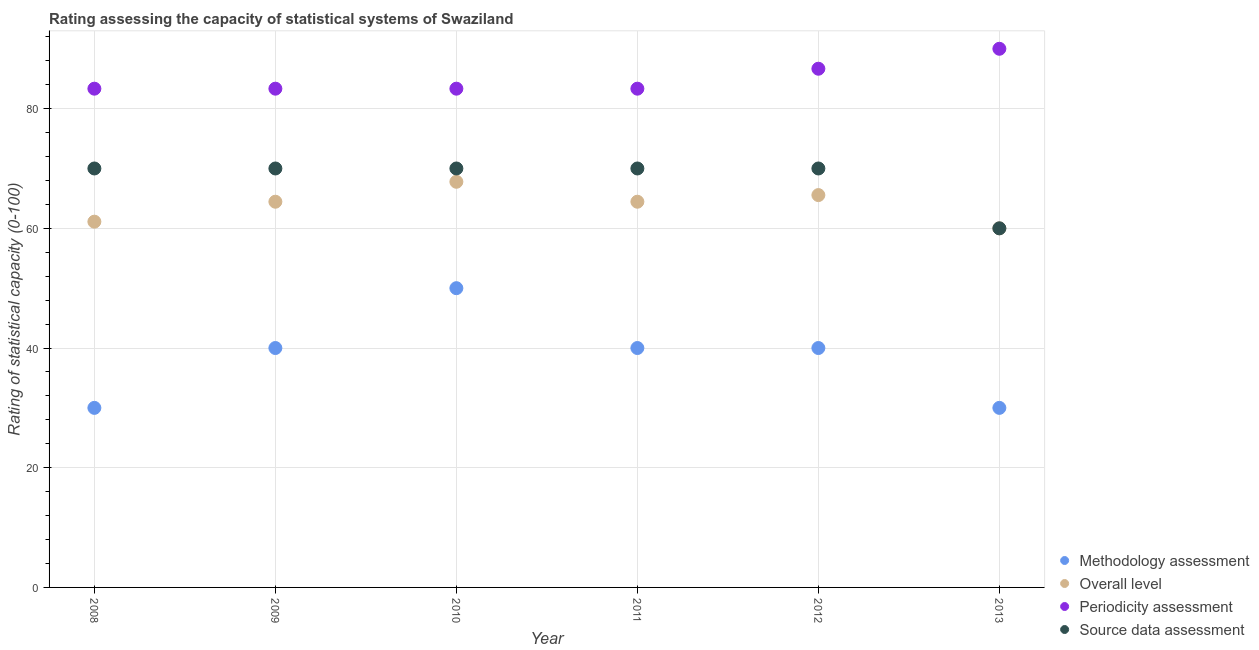What is the methodology assessment rating in 2008?
Give a very brief answer. 30. Across all years, what is the maximum methodology assessment rating?
Provide a short and direct response. 50. Across all years, what is the minimum overall level rating?
Provide a short and direct response. 60. In which year was the source data assessment rating maximum?
Your response must be concise. 2008. In which year was the periodicity assessment rating minimum?
Your answer should be compact. 2008. What is the total methodology assessment rating in the graph?
Offer a terse response. 230. What is the difference between the overall level rating in 2010 and that in 2012?
Provide a short and direct response. 2.22. What is the difference between the source data assessment rating in 2010 and the periodicity assessment rating in 2008?
Offer a terse response. -13.33. What is the average source data assessment rating per year?
Offer a terse response. 68.33. In the year 2010, what is the difference between the periodicity assessment rating and source data assessment rating?
Keep it short and to the point. 13.33. What is the ratio of the source data assessment rating in 2008 to that in 2009?
Offer a terse response. 1. Is the methodology assessment rating in 2008 less than that in 2012?
Give a very brief answer. Yes. What is the difference between the highest and the second highest periodicity assessment rating?
Your response must be concise. 3.33. What is the difference between the highest and the lowest overall level rating?
Your response must be concise. 7.78. In how many years, is the periodicity assessment rating greater than the average periodicity assessment rating taken over all years?
Make the answer very short. 2. Is it the case that in every year, the sum of the overall level rating and methodology assessment rating is greater than the sum of periodicity assessment rating and source data assessment rating?
Offer a very short reply. No. Is the methodology assessment rating strictly greater than the overall level rating over the years?
Make the answer very short. No. Is the overall level rating strictly less than the source data assessment rating over the years?
Your answer should be compact. No. How many dotlines are there?
Provide a succinct answer. 4. What is the difference between two consecutive major ticks on the Y-axis?
Offer a very short reply. 20. Does the graph contain any zero values?
Provide a succinct answer. No. Does the graph contain grids?
Keep it short and to the point. Yes. Where does the legend appear in the graph?
Keep it short and to the point. Bottom right. How many legend labels are there?
Make the answer very short. 4. How are the legend labels stacked?
Offer a terse response. Vertical. What is the title of the graph?
Offer a terse response. Rating assessing the capacity of statistical systems of Swaziland. Does "Labor Taxes" appear as one of the legend labels in the graph?
Ensure brevity in your answer.  No. What is the label or title of the Y-axis?
Provide a short and direct response. Rating of statistical capacity (0-100). What is the Rating of statistical capacity (0-100) of Methodology assessment in 2008?
Offer a terse response. 30. What is the Rating of statistical capacity (0-100) of Overall level in 2008?
Keep it short and to the point. 61.11. What is the Rating of statistical capacity (0-100) of Periodicity assessment in 2008?
Offer a very short reply. 83.33. What is the Rating of statistical capacity (0-100) of Source data assessment in 2008?
Provide a succinct answer. 70. What is the Rating of statistical capacity (0-100) of Overall level in 2009?
Your answer should be very brief. 64.44. What is the Rating of statistical capacity (0-100) in Periodicity assessment in 2009?
Your response must be concise. 83.33. What is the Rating of statistical capacity (0-100) in Source data assessment in 2009?
Your response must be concise. 70. What is the Rating of statistical capacity (0-100) in Overall level in 2010?
Provide a succinct answer. 67.78. What is the Rating of statistical capacity (0-100) of Periodicity assessment in 2010?
Give a very brief answer. 83.33. What is the Rating of statistical capacity (0-100) in Methodology assessment in 2011?
Keep it short and to the point. 40. What is the Rating of statistical capacity (0-100) of Overall level in 2011?
Your answer should be very brief. 64.44. What is the Rating of statistical capacity (0-100) in Periodicity assessment in 2011?
Your answer should be compact. 83.33. What is the Rating of statistical capacity (0-100) of Source data assessment in 2011?
Keep it short and to the point. 70. What is the Rating of statistical capacity (0-100) of Overall level in 2012?
Offer a very short reply. 65.56. What is the Rating of statistical capacity (0-100) of Periodicity assessment in 2012?
Offer a very short reply. 86.67. What is the Rating of statistical capacity (0-100) in Methodology assessment in 2013?
Keep it short and to the point. 30. Across all years, what is the maximum Rating of statistical capacity (0-100) of Overall level?
Give a very brief answer. 67.78. Across all years, what is the minimum Rating of statistical capacity (0-100) of Methodology assessment?
Keep it short and to the point. 30. Across all years, what is the minimum Rating of statistical capacity (0-100) of Periodicity assessment?
Your response must be concise. 83.33. What is the total Rating of statistical capacity (0-100) in Methodology assessment in the graph?
Offer a very short reply. 230. What is the total Rating of statistical capacity (0-100) of Overall level in the graph?
Offer a terse response. 383.33. What is the total Rating of statistical capacity (0-100) of Periodicity assessment in the graph?
Provide a succinct answer. 510. What is the total Rating of statistical capacity (0-100) of Source data assessment in the graph?
Give a very brief answer. 410. What is the difference between the Rating of statistical capacity (0-100) in Overall level in 2008 and that in 2009?
Offer a terse response. -3.33. What is the difference between the Rating of statistical capacity (0-100) of Periodicity assessment in 2008 and that in 2009?
Your response must be concise. 0. What is the difference between the Rating of statistical capacity (0-100) in Overall level in 2008 and that in 2010?
Provide a short and direct response. -6.67. What is the difference between the Rating of statistical capacity (0-100) of Periodicity assessment in 2008 and that in 2010?
Provide a succinct answer. 0. What is the difference between the Rating of statistical capacity (0-100) in Source data assessment in 2008 and that in 2010?
Your answer should be very brief. 0. What is the difference between the Rating of statistical capacity (0-100) in Methodology assessment in 2008 and that in 2011?
Offer a terse response. -10. What is the difference between the Rating of statistical capacity (0-100) in Periodicity assessment in 2008 and that in 2011?
Offer a terse response. 0. What is the difference between the Rating of statistical capacity (0-100) of Source data assessment in 2008 and that in 2011?
Keep it short and to the point. 0. What is the difference between the Rating of statistical capacity (0-100) in Methodology assessment in 2008 and that in 2012?
Keep it short and to the point. -10. What is the difference between the Rating of statistical capacity (0-100) of Overall level in 2008 and that in 2012?
Provide a short and direct response. -4.44. What is the difference between the Rating of statistical capacity (0-100) in Periodicity assessment in 2008 and that in 2012?
Ensure brevity in your answer.  -3.33. What is the difference between the Rating of statistical capacity (0-100) of Source data assessment in 2008 and that in 2012?
Give a very brief answer. 0. What is the difference between the Rating of statistical capacity (0-100) of Methodology assessment in 2008 and that in 2013?
Provide a succinct answer. 0. What is the difference between the Rating of statistical capacity (0-100) in Overall level in 2008 and that in 2013?
Offer a terse response. 1.11. What is the difference between the Rating of statistical capacity (0-100) of Periodicity assessment in 2008 and that in 2013?
Ensure brevity in your answer.  -6.67. What is the difference between the Rating of statistical capacity (0-100) in Methodology assessment in 2009 and that in 2010?
Offer a terse response. -10. What is the difference between the Rating of statistical capacity (0-100) in Source data assessment in 2009 and that in 2010?
Keep it short and to the point. 0. What is the difference between the Rating of statistical capacity (0-100) in Methodology assessment in 2009 and that in 2011?
Keep it short and to the point. 0. What is the difference between the Rating of statistical capacity (0-100) in Periodicity assessment in 2009 and that in 2011?
Make the answer very short. 0. What is the difference between the Rating of statistical capacity (0-100) of Source data assessment in 2009 and that in 2011?
Ensure brevity in your answer.  0. What is the difference between the Rating of statistical capacity (0-100) in Overall level in 2009 and that in 2012?
Keep it short and to the point. -1.11. What is the difference between the Rating of statistical capacity (0-100) of Periodicity assessment in 2009 and that in 2012?
Provide a succinct answer. -3.33. What is the difference between the Rating of statistical capacity (0-100) of Source data assessment in 2009 and that in 2012?
Your response must be concise. 0. What is the difference between the Rating of statistical capacity (0-100) of Overall level in 2009 and that in 2013?
Offer a terse response. 4.44. What is the difference between the Rating of statistical capacity (0-100) in Periodicity assessment in 2009 and that in 2013?
Offer a very short reply. -6.67. What is the difference between the Rating of statistical capacity (0-100) of Source data assessment in 2009 and that in 2013?
Keep it short and to the point. 10. What is the difference between the Rating of statistical capacity (0-100) of Overall level in 2010 and that in 2011?
Ensure brevity in your answer.  3.33. What is the difference between the Rating of statistical capacity (0-100) of Source data assessment in 2010 and that in 2011?
Make the answer very short. 0. What is the difference between the Rating of statistical capacity (0-100) of Overall level in 2010 and that in 2012?
Provide a succinct answer. 2.22. What is the difference between the Rating of statistical capacity (0-100) of Source data assessment in 2010 and that in 2012?
Provide a succinct answer. 0. What is the difference between the Rating of statistical capacity (0-100) in Overall level in 2010 and that in 2013?
Make the answer very short. 7.78. What is the difference between the Rating of statistical capacity (0-100) in Periodicity assessment in 2010 and that in 2013?
Provide a succinct answer. -6.67. What is the difference between the Rating of statistical capacity (0-100) in Methodology assessment in 2011 and that in 2012?
Offer a very short reply. 0. What is the difference between the Rating of statistical capacity (0-100) of Overall level in 2011 and that in 2012?
Provide a succinct answer. -1.11. What is the difference between the Rating of statistical capacity (0-100) in Source data assessment in 2011 and that in 2012?
Provide a short and direct response. 0. What is the difference between the Rating of statistical capacity (0-100) of Overall level in 2011 and that in 2013?
Make the answer very short. 4.44. What is the difference between the Rating of statistical capacity (0-100) of Periodicity assessment in 2011 and that in 2013?
Make the answer very short. -6.67. What is the difference between the Rating of statistical capacity (0-100) of Source data assessment in 2011 and that in 2013?
Provide a short and direct response. 10. What is the difference between the Rating of statistical capacity (0-100) in Methodology assessment in 2012 and that in 2013?
Make the answer very short. 10. What is the difference between the Rating of statistical capacity (0-100) in Overall level in 2012 and that in 2013?
Offer a very short reply. 5.56. What is the difference between the Rating of statistical capacity (0-100) of Periodicity assessment in 2012 and that in 2013?
Make the answer very short. -3.33. What is the difference between the Rating of statistical capacity (0-100) of Source data assessment in 2012 and that in 2013?
Your response must be concise. 10. What is the difference between the Rating of statistical capacity (0-100) of Methodology assessment in 2008 and the Rating of statistical capacity (0-100) of Overall level in 2009?
Your answer should be very brief. -34.44. What is the difference between the Rating of statistical capacity (0-100) in Methodology assessment in 2008 and the Rating of statistical capacity (0-100) in Periodicity assessment in 2009?
Offer a terse response. -53.33. What is the difference between the Rating of statistical capacity (0-100) in Overall level in 2008 and the Rating of statistical capacity (0-100) in Periodicity assessment in 2009?
Provide a short and direct response. -22.22. What is the difference between the Rating of statistical capacity (0-100) in Overall level in 2008 and the Rating of statistical capacity (0-100) in Source data assessment in 2009?
Ensure brevity in your answer.  -8.89. What is the difference between the Rating of statistical capacity (0-100) in Periodicity assessment in 2008 and the Rating of statistical capacity (0-100) in Source data assessment in 2009?
Provide a short and direct response. 13.33. What is the difference between the Rating of statistical capacity (0-100) in Methodology assessment in 2008 and the Rating of statistical capacity (0-100) in Overall level in 2010?
Ensure brevity in your answer.  -37.78. What is the difference between the Rating of statistical capacity (0-100) in Methodology assessment in 2008 and the Rating of statistical capacity (0-100) in Periodicity assessment in 2010?
Your response must be concise. -53.33. What is the difference between the Rating of statistical capacity (0-100) in Methodology assessment in 2008 and the Rating of statistical capacity (0-100) in Source data assessment in 2010?
Provide a short and direct response. -40. What is the difference between the Rating of statistical capacity (0-100) of Overall level in 2008 and the Rating of statistical capacity (0-100) of Periodicity assessment in 2010?
Ensure brevity in your answer.  -22.22. What is the difference between the Rating of statistical capacity (0-100) of Overall level in 2008 and the Rating of statistical capacity (0-100) of Source data assessment in 2010?
Make the answer very short. -8.89. What is the difference between the Rating of statistical capacity (0-100) of Periodicity assessment in 2008 and the Rating of statistical capacity (0-100) of Source data assessment in 2010?
Ensure brevity in your answer.  13.33. What is the difference between the Rating of statistical capacity (0-100) in Methodology assessment in 2008 and the Rating of statistical capacity (0-100) in Overall level in 2011?
Your answer should be compact. -34.44. What is the difference between the Rating of statistical capacity (0-100) of Methodology assessment in 2008 and the Rating of statistical capacity (0-100) of Periodicity assessment in 2011?
Your answer should be compact. -53.33. What is the difference between the Rating of statistical capacity (0-100) of Methodology assessment in 2008 and the Rating of statistical capacity (0-100) of Source data assessment in 2011?
Your answer should be very brief. -40. What is the difference between the Rating of statistical capacity (0-100) of Overall level in 2008 and the Rating of statistical capacity (0-100) of Periodicity assessment in 2011?
Offer a very short reply. -22.22. What is the difference between the Rating of statistical capacity (0-100) in Overall level in 2008 and the Rating of statistical capacity (0-100) in Source data assessment in 2011?
Give a very brief answer. -8.89. What is the difference between the Rating of statistical capacity (0-100) of Periodicity assessment in 2008 and the Rating of statistical capacity (0-100) of Source data assessment in 2011?
Offer a terse response. 13.33. What is the difference between the Rating of statistical capacity (0-100) in Methodology assessment in 2008 and the Rating of statistical capacity (0-100) in Overall level in 2012?
Offer a very short reply. -35.56. What is the difference between the Rating of statistical capacity (0-100) in Methodology assessment in 2008 and the Rating of statistical capacity (0-100) in Periodicity assessment in 2012?
Keep it short and to the point. -56.67. What is the difference between the Rating of statistical capacity (0-100) in Overall level in 2008 and the Rating of statistical capacity (0-100) in Periodicity assessment in 2012?
Give a very brief answer. -25.56. What is the difference between the Rating of statistical capacity (0-100) in Overall level in 2008 and the Rating of statistical capacity (0-100) in Source data assessment in 2012?
Your answer should be compact. -8.89. What is the difference between the Rating of statistical capacity (0-100) of Periodicity assessment in 2008 and the Rating of statistical capacity (0-100) of Source data assessment in 2012?
Provide a succinct answer. 13.33. What is the difference between the Rating of statistical capacity (0-100) of Methodology assessment in 2008 and the Rating of statistical capacity (0-100) of Overall level in 2013?
Provide a short and direct response. -30. What is the difference between the Rating of statistical capacity (0-100) in Methodology assessment in 2008 and the Rating of statistical capacity (0-100) in Periodicity assessment in 2013?
Your answer should be very brief. -60. What is the difference between the Rating of statistical capacity (0-100) of Methodology assessment in 2008 and the Rating of statistical capacity (0-100) of Source data assessment in 2013?
Offer a very short reply. -30. What is the difference between the Rating of statistical capacity (0-100) in Overall level in 2008 and the Rating of statistical capacity (0-100) in Periodicity assessment in 2013?
Provide a succinct answer. -28.89. What is the difference between the Rating of statistical capacity (0-100) of Periodicity assessment in 2008 and the Rating of statistical capacity (0-100) of Source data assessment in 2013?
Give a very brief answer. 23.33. What is the difference between the Rating of statistical capacity (0-100) of Methodology assessment in 2009 and the Rating of statistical capacity (0-100) of Overall level in 2010?
Offer a very short reply. -27.78. What is the difference between the Rating of statistical capacity (0-100) of Methodology assessment in 2009 and the Rating of statistical capacity (0-100) of Periodicity assessment in 2010?
Ensure brevity in your answer.  -43.33. What is the difference between the Rating of statistical capacity (0-100) in Overall level in 2009 and the Rating of statistical capacity (0-100) in Periodicity assessment in 2010?
Your response must be concise. -18.89. What is the difference between the Rating of statistical capacity (0-100) of Overall level in 2009 and the Rating of statistical capacity (0-100) of Source data assessment in 2010?
Make the answer very short. -5.56. What is the difference between the Rating of statistical capacity (0-100) in Periodicity assessment in 2009 and the Rating of statistical capacity (0-100) in Source data assessment in 2010?
Give a very brief answer. 13.33. What is the difference between the Rating of statistical capacity (0-100) in Methodology assessment in 2009 and the Rating of statistical capacity (0-100) in Overall level in 2011?
Your answer should be compact. -24.44. What is the difference between the Rating of statistical capacity (0-100) of Methodology assessment in 2009 and the Rating of statistical capacity (0-100) of Periodicity assessment in 2011?
Provide a succinct answer. -43.33. What is the difference between the Rating of statistical capacity (0-100) in Overall level in 2009 and the Rating of statistical capacity (0-100) in Periodicity assessment in 2011?
Your answer should be very brief. -18.89. What is the difference between the Rating of statistical capacity (0-100) of Overall level in 2009 and the Rating of statistical capacity (0-100) of Source data assessment in 2011?
Your answer should be compact. -5.56. What is the difference between the Rating of statistical capacity (0-100) in Periodicity assessment in 2009 and the Rating of statistical capacity (0-100) in Source data assessment in 2011?
Make the answer very short. 13.33. What is the difference between the Rating of statistical capacity (0-100) in Methodology assessment in 2009 and the Rating of statistical capacity (0-100) in Overall level in 2012?
Offer a terse response. -25.56. What is the difference between the Rating of statistical capacity (0-100) of Methodology assessment in 2009 and the Rating of statistical capacity (0-100) of Periodicity assessment in 2012?
Provide a succinct answer. -46.67. What is the difference between the Rating of statistical capacity (0-100) of Methodology assessment in 2009 and the Rating of statistical capacity (0-100) of Source data assessment in 2012?
Make the answer very short. -30. What is the difference between the Rating of statistical capacity (0-100) in Overall level in 2009 and the Rating of statistical capacity (0-100) in Periodicity assessment in 2012?
Offer a very short reply. -22.22. What is the difference between the Rating of statistical capacity (0-100) in Overall level in 2009 and the Rating of statistical capacity (0-100) in Source data assessment in 2012?
Give a very brief answer. -5.56. What is the difference between the Rating of statistical capacity (0-100) of Periodicity assessment in 2009 and the Rating of statistical capacity (0-100) of Source data assessment in 2012?
Offer a terse response. 13.33. What is the difference between the Rating of statistical capacity (0-100) in Methodology assessment in 2009 and the Rating of statistical capacity (0-100) in Overall level in 2013?
Ensure brevity in your answer.  -20. What is the difference between the Rating of statistical capacity (0-100) of Overall level in 2009 and the Rating of statistical capacity (0-100) of Periodicity assessment in 2013?
Keep it short and to the point. -25.56. What is the difference between the Rating of statistical capacity (0-100) of Overall level in 2009 and the Rating of statistical capacity (0-100) of Source data assessment in 2013?
Give a very brief answer. 4.44. What is the difference between the Rating of statistical capacity (0-100) of Periodicity assessment in 2009 and the Rating of statistical capacity (0-100) of Source data assessment in 2013?
Your answer should be compact. 23.33. What is the difference between the Rating of statistical capacity (0-100) of Methodology assessment in 2010 and the Rating of statistical capacity (0-100) of Overall level in 2011?
Offer a very short reply. -14.44. What is the difference between the Rating of statistical capacity (0-100) of Methodology assessment in 2010 and the Rating of statistical capacity (0-100) of Periodicity assessment in 2011?
Offer a terse response. -33.33. What is the difference between the Rating of statistical capacity (0-100) of Overall level in 2010 and the Rating of statistical capacity (0-100) of Periodicity assessment in 2011?
Offer a very short reply. -15.56. What is the difference between the Rating of statistical capacity (0-100) in Overall level in 2010 and the Rating of statistical capacity (0-100) in Source data assessment in 2011?
Offer a very short reply. -2.22. What is the difference between the Rating of statistical capacity (0-100) of Periodicity assessment in 2010 and the Rating of statistical capacity (0-100) of Source data assessment in 2011?
Make the answer very short. 13.33. What is the difference between the Rating of statistical capacity (0-100) in Methodology assessment in 2010 and the Rating of statistical capacity (0-100) in Overall level in 2012?
Provide a succinct answer. -15.56. What is the difference between the Rating of statistical capacity (0-100) of Methodology assessment in 2010 and the Rating of statistical capacity (0-100) of Periodicity assessment in 2012?
Your response must be concise. -36.67. What is the difference between the Rating of statistical capacity (0-100) in Methodology assessment in 2010 and the Rating of statistical capacity (0-100) in Source data assessment in 2012?
Your response must be concise. -20. What is the difference between the Rating of statistical capacity (0-100) of Overall level in 2010 and the Rating of statistical capacity (0-100) of Periodicity assessment in 2012?
Provide a succinct answer. -18.89. What is the difference between the Rating of statistical capacity (0-100) of Overall level in 2010 and the Rating of statistical capacity (0-100) of Source data assessment in 2012?
Offer a very short reply. -2.22. What is the difference between the Rating of statistical capacity (0-100) in Periodicity assessment in 2010 and the Rating of statistical capacity (0-100) in Source data assessment in 2012?
Give a very brief answer. 13.33. What is the difference between the Rating of statistical capacity (0-100) in Methodology assessment in 2010 and the Rating of statistical capacity (0-100) in Overall level in 2013?
Provide a short and direct response. -10. What is the difference between the Rating of statistical capacity (0-100) in Methodology assessment in 2010 and the Rating of statistical capacity (0-100) in Periodicity assessment in 2013?
Your response must be concise. -40. What is the difference between the Rating of statistical capacity (0-100) of Overall level in 2010 and the Rating of statistical capacity (0-100) of Periodicity assessment in 2013?
Ensure brevity in your answer.  -22.22. What is the difference between the Rating of statistical capacity (0-100) in Overall level in 2010 and the Rating of statistical capacity (0-100) in Source data assessment in 2013?
Make the answer very short. 7.78. What is the difference between the Rating of statistical capacity (0-100) in Periodicity assessment in 2010 and the Rating of statistical capacity (0-100) in Source data assessment in 2013?
Provide a succinct answer. 23.33. What is the difference between the Rating of statistical capacity (0-100) of Methodology assessment in 2011 and the Rating of statistical capacity (0-100) of Overall level in 2012?
Keep it short and to the point. -25.56. What is the difference between the Rating of statistical capacity (0-100) of Methodology assessment in 2011 and the Rating of statistical capacity (0-100) of Periodicity assessment in 2012?
Provide a succinct answer. -46.67. What is the difference between the Rating of statistical capacity (0-100) of Overall level in 2011 and the Rating of statistical capacity (0-100) of Periodicity assessment in 2012?
Your answer should be compact. -22.22. What is the difference between the Rating of statistical capacity (0-100) in Overall level in 2011 and the Rating of statistical capacity (0-100) in Source data assessment in 2012?
Provide a short and direct response. -5.56. What is the difference between the Rating of statistical capacity (0-100) in Periodicity assessment in 2011 and the Rating of statistical capacity (0-100) in Source data assessment in 2012?
Provide a succinct answer. 13.33. What is the difference between the Rating of statistical capacity (0-100) in Methodology assessment in 2011 and the Rating of statistical capacity (0-100) in Overall level in 2013?
Offer a very short reply. -20. What is the difference between the Rating of statistical capacity (0-100) in Overall level in 2011 and the Rating of statistical capacity (0-100) in Periodicity assessment in 2013?
Your answer should be very brief. -25.56. What is the difference between the Rating of statistical capacity (0-100) of Overall level in 2011 and the Rating of statistical capacity (0-100) of Source data assessment in 2013?
Offer a very short reply. 4.44. What is the difference between the Rating of statistical capacity (0-100) of Periodicity assessment in 2011 and the Rating of statistical capacity (0-100) of Source data assessment in 2013?
Make the answer very short. 23.33. What is the difference between the Rating of statistical capacity (0-100) of Methodology assessment in 2012 and the Rating of statistical capacity (0-100) of Overall level in 2013?
Provide a short and direct response. -20. What is the difference between the Rating of statistical capacity (0-100) of Methodology assessment in 2012 and the Rating of statistical capacity (0-100) of Periodicity assessment in 2013?
Your answer should be very brief. -50. What is the difference between the Rating of statistical capacity (0-100) of Overall level in 2012 and the Rating of statistical capacity (0-100) of Periodicity assessment in 2013?
Make the answer very short. -24.44. What is the difference between the Rating of statistical capacity (0-100) in Overall level in 2012 and the Rating of statistical capacity (0-100) in Source data assessment in 2013?
Provide a succinct answer. 5.56. What is the difference between the Rating of statistical capacity (0-100) in Periodicity assessment in 2012 and the Rating of statistical capacity (0-100) in Source data assessment in 2013?
Offer a terse response. 26.67. What is the average Rating of statistical capacity (0-100) of Methodology assessment per year?
Your answer should be compact. 38.33. What is the average Rating of statistical capacity (0-100) in Overall level per year?
Offer a very short reply. 63.89. What is the average Rating of statistical capacity (0-100) in Periodicity assessment per year?
Your answer should be very brief. 85. What is the average Rating of statistical capacity (0-100) in Source data assessment per year?
Give a very brief answer. 68.33. In the year 2008, what is the difference between the Rating of statistical capacity (0-100) in Methodology assessment and Rating of statistical capacity (0-100) in Overall level?
Provide a short and direct response. -31.11. In the year 2008, what is the difference between the Rating of statistical capacity (0-100) in Methodology assessment and Rating of statistical capacity (0-100) in Periodicity assessment?
Your answer should be compact. -53.33. In the year 2008, what is the difference between the Rating of statistical capacity (0-100) in Methodology assessment and Rating of statistical capacity (0-100) in Source data assessment?
Your answer should be compact. -40. In the year 2008, what is the difference between the Rating of statistical capacity (0-100) of Overall level and Rating of statistical capacity (0-100) of Periodicity assessment?
Ensure brevity in your answer.  -22.22. In the year 2008, what is the difference between the Rating of statistical capacity (0-100) in Overall level and Rating of statistical capacity (0-100) in Source data assessment?
Give a very brief answer. -8.89. In the year 2008, what is the difference between the Rating of statistical capacity (0-100) of Periodicity assessment and Rating of statistical capacity (0-100) of Source data assessment?
Ensure brevity in your answer.  13.33. In the year 2009, what is the difference between the Rating of statistical capacity (0-100) of Methodology assessment and Rating of statistical capacity (0-100) of Overall level?
Ensure brevity in your answer.  -24.44. In the year 2009, what is the difference between the Rating of statistical capacity (0-100) of Methodology assessment and Rating of statistical capacity (0-100) of Periodicity assessment?
Your answer should be compact. -43.33. In the year 2009, what is the difference between the Rating of statistical capacity (0-100) in Overall level and Rating of statistical capacity (0-100) in Periodicity assessment?
Your answer should be compact. -18.89. In the year 2009, what is the difference between the Rating of statistical capacity (0-100) in Overall level and Rating of statistical capacity (0-100) in Source data assessment?
Make the answer very short. -5.56. In the year 2009, what is the difference between the Rating of statistical capacity (0-100) of Periodicity assessment and Rating of statistical capacity (0-100) of Source data assessment?
Provide a short and direct response. 13.33. In the year 2010, what is the difference between the Rating of statistical capacity (0-100) in Methodology assessment and Rating of statistical capacity (0-100) in Overall level?
Offer a terse response. -17.78. In the year 2010, what is the difference between the Rating of statistical capacity (0-100) of Methodology assessment and Rating of statistical capacity (0-100) of Periodicity assessment?
Offer a very short reply. -33.33. In the year 2010, what is the difference between the Rating of statistical capacity (0-100) in Overall level and Rating of statistical capacity (0-100) in Periodicity assessment?
Your answer should be very brief. -15.56. In the year 2010, what is the difference between the Rating of statistical capacity (0-100) in Overall level and Rating of statistical capacity (0-100) in Source data assessment?
Your response must be concise. -2.22. In the year 2010, what is the difference between the Rating of statistical capacity (0-100) in Periodicity assessment and Rating of statistical capacity (0-100) in Source data assessment?
Your answer should be compact. 13.33. In the year 2011, what is the difference between the Rating of statistical capacity (0-100) of Methodology assessment and Rating of statistical capacity (0-100) of Overall level?
Your answer should be compact. -24.44. In the year 2011, what is the difference between the Rating of statistical capacity (0-100) of Methodology assessment and Rating of statistical capacity (0-100) of Periodicity assessment?
Offer a very short reply. -43.33. In the year 2011, what is the difference between the Rating of statistical capacity (0-100) of Overall level and Rating of statistical capacity (0-100) of Periodicity assessment?
Keep it short and to the point. -18.89. In the year 2011, what is the difference between the Rating of statistical capacity (0-100) of Overall level and Rating of statistical capacity (0-100) of Source data assessment?
Your answer should be compact. -5.56. In the year 2011, what is the difference between the Rating of statistical capacity (0-100) of Periodicity assessment and Rating of statistical capacity (0-100) of Source data assessment?
Make the answer very short. 13.33. In the year 2012, what is the difference between the Rating of statistical capacity (0-100) in Methodology assessment and Rating of statistical capacity (0-100) in Overall level?
Provide a succinct answer. -25.56. In the year 2012, what is the difference between the Rating of statistical capacity (0-100) of Methodology assessment and Rating of statistical capacity (0-100) of Periodicity assessment?
Offer a terse response. -46.67. In the year 2012, what is the difference between the Rating of statistical capacity (0-100) in Methodology assessment and Rating of statistical capacity (0-100) in Source data assessment?
Offer a very short reply. -30. In the year 2012, what is the difference between the Rating of statistical capacity (0-100) of Overall level and Rating of statistical capacity (0-100) of Periodicity assessment?
Offer a terse response. -21.11. In the year 2012, what is the difference between the Rating of statistical capacity (0-100) in Overall level and Rating of statistical capacity (0-100) in Source data assessment?
Provide a succinct answer. -4.44. In the year 2012, what is the difference between the Rating of statistical capacity (0-100) of Periodicity assessment and Rating of statistical capacity (0-100) of Source data assessment?
Your answer should be very brief. 16.67. In the year 2013, what is the difference between the Rating of statistical capacity (0-100) of Methodology assessment and Rating of statistical capacity (0-100) of Periodicity assessment?
Provide a short and direct response. -60. In the year 2013, what is the difference between the Rating of statistical capacity (0-100) of Methodology assessment and Rating of statistical capacity (0-100) of Source data assessment?
Offer a very short reply. -30. In the year 2013, what is the difference between the Rating of statistical capacity (0-100) of Overall level and Rating of statistical capacity (0-100) of Source data assessment?
Make the answer very short. 0. What is the ratio of the Rating of statistical capacity (0-100) in Overall level in 2008 to that in 2009?
Ensure brevity in your answer.  0.95. What is the ratio of the Rating of statistical capacity (0-100) in Source data assessment in 2008 to that in 2009?
Your response must be concise. 1. What is the ratio of the Rating of statistical capacity (0-100) of Methodology assessment in 2008 to that in 2010?
Offer a terse response. 0.6. What is the ratio of the Rating of statistical capacity (0-100) in Overall level in 2008 to that in 2010?
Keep it short and to the point. 0.9. What is the ratio of the Rating of statistical capacity (0-100) in Periodicity assessment in 2008 to that in 2010?
Make the answer very short. 1. What is the ratio of the Rating of statistical capacity (0-100) in Methodology assessment in 2008 to that in 2011?
Keep it short and to the point. 0.75. What is the ratio of the Rating of statistical capacity (0-100) in Overall level in 2008 to that in 2011?
Give a very brief answer. 0.95. What is the ratio of the Rating of statistical capacity (0-100) of Periodicity assessment in 2008 to that in 2011?
Keep it short and to the point. 1. What is the ratio of the Rating of statistical capacity (0-100) in Source data assessment in 2008 to that in 2011?
Provide a succinct answer. 1. What is the ratio of the Rating of statistical capacity (0-100) of Methodology assessment in 2008 to that in 2012?
Give a very brief answer. 0.75. What is the ratio of the Rating of statistical capacity (0-100) of Overall level in 2008 to that in 2012?
Make the answer very short. 0.93. What is the ratio of the Rating of statistical capacity (0-100) in Periodicity assessment in 2008 to that in 2012?
Offer a very short reply. 0.96. What is the ratio of the Rating of statistical capacity (0-100) of Source data assessment in 2008 to that in 2012?
Give a very brief answer. 1. What is the ratio of the Rating of statistical capacity (0-100) of Methodology assessment in 2008 to that in 2013?
Your answer should be very brief. 1. What is the ratio of the Rating of statistical capacity (0-100) in Overall level in 2008 to that in 2013?
Keep it short and to the point. 1.02. What is the ratio of the Rating of statistical capacity (0-100) in Periodicity assessment in 2008 to that in 2013?
Offer a very short reply. 0.93. What is the ratio of the Rating of statistical capacity (0-100) in Overall level in 2009 to that in 2010?
Keep it short and to the point. 0.95. What is the ratio of the Rating of statistical capacity (0-100) in Periodicity assessment in 2009 to that in 2010?
Provide a short and direct response. 1. What is the ratio of the Rating of statistical capacity (0-100) in Source data assessment in 2009 to that in 2010?
Provide a succinct answer. 1. What is the ratio of the Rating of statistical capacity (0-100) of Methodology assessment in 2009 to that in 2011?
Offer a terse response. 1. What is the ratio of the Rating of statistical capacity (0-100) in Overall level in 2009 to that in 2011?
Ensure brevity in your answer.  1. What is the ratio of the Rating of statistical capacity (0-100) in Source data assessment in 2009 to that in 2011?
Make the answer very short. 1. What is the ratio of the Rating of statistical capacity (0-100) of Methodology assessment in 2009 to that in 2012?
Your answer should be compact. 1. What is the ratio of the Rating of statistical capacity (0-100) of Overall level in 2009 to that in 2012?
Make the answer very short. 0.98. What is the ratio of the Rating of statistical capacity (0-100) in Periodicity assessment in 2009 to that in 2012?
Your answer should be very brief. 0.96. What is the ratio of the Rating of statistical capacity (0-100) of Source data assessment in 2009 to that in 2012?
Your response must be concise. 1. What is the ratio of the Rating of statistical capacity (0-100) of Overall level in 2009 to that in 2013?
Give a very brief answer. 1.07. What is the ratio of the Rating of statistical capacity (0-100) in Periodicity assessment in 2009 to that in 2013?
Ensure brevity in your answer.  0.93. What is the ratio of the Rating of statistical capacity (0-100) of Overall level in 2010 to that in 2011?
Give a very brief answer. 1.05. What is the ratio of the Rating of statistical capacity (0-100) in Methodology assessment in 2010 to that in 2012?
Keep it short and to the point. 1.25. What is the ratio of the Rating of statistical capacity (0-100) in Overall level in 2010 to that in 2012?
Your answer should be compact. 1.03. What is the ratio of the Rating of statistical capacity (0-100) of Periodicity assessment in 2010 to that in 2012?
Provide a short and direct response. 0.96. What is the ratio of the Rating of statistical capacity (0-100) in Source data assessment in 2010 to that in 2012?
Make the answer very short. 1. What is the ratio of the Rating of statistical capacity (0-100) in Methodology assessment in 2010 to that in 2013?
Keep it short and to the point. 1.67. What is the ratio of the Rating of statistical capacity (0-100) of Overall level in 2010 to that in 2013?
Your response must be concise. 1.13. What is the ratio of the Rating of statistical capacity (0-100) in Periodicity assessment in 2010 to that in 2013?
Ensure brevity in your answer.  0.93. What is the ratio of the Rating of statistical capacity (0-100) in Overall level in 2011 to that in 2012?
Keep it short and to the point. 0.98. What is the ratio of the Rating of statistical capacity (0-100) in Periodicity assessment in 2011 to that in 2012?
Your response must be concise. 0.96. What is the ratio of the Rating of statistical capacity (0-100) of Methodology assessment in 2011 to that in 2013?
Your answer should be very brief. 1.33. What is the ratio of the Rating of statistical capacity (0-100) of Overall level in 2011 to that in 2013?
Offer a terse response. 1.07. What is the ratio of the Rating of statistical capacity (0-100) in Periodicity assessment in 2011 to that in 2013?
Your answer should be very brief. 0.93. What is the ratio of the Rating of statistical capacity (0-100) of Source data assessment in 2011 to that in 2013?
Your answer should be very brief. 1.17. What is the ratio of the Rating of statistical capacity (0-100) in Overall level in 2012 to that in 2013?
Your response must be concise. 1.09. What is the ratio of the Rating of statistical capacity (0-100) of Periodicity assessment in 2012 to that in 2013?
Give a very brief answer. 0.96. What is the difference between the highest and the second highest Rating of statistical capacity (0-100) of Methodology assessment?
Your answer should be compact. 10. What is the difference between the highest and the second highest Rating of statistical capacity (0-100) of Overall level?
Your response must be concise. 2.22. What is the difference between the highest and the second highest Rating of statistical capacity (0-100) of Periodicity assessment?
Your answer should be compact. 3.33. What is the difference between the highest and the second highest Rating of statistical capacity (0-100) of Source data assessment?
Ensure brevity in your answer.  0. What is the difference between the highest and the lowest Rating of statistical capacity (0-100) of Methodology assessment?
Your response must be concise. 20. What is the difference between the highest and the lowest Rating of statistical capacity (0-100) of Overall level?
Offer a very short reply. 7.78. What is the difference between the highest and the lowest Rating of statistical capacity (0-100) of Source data assessment?
Make the answer very short. 10. 